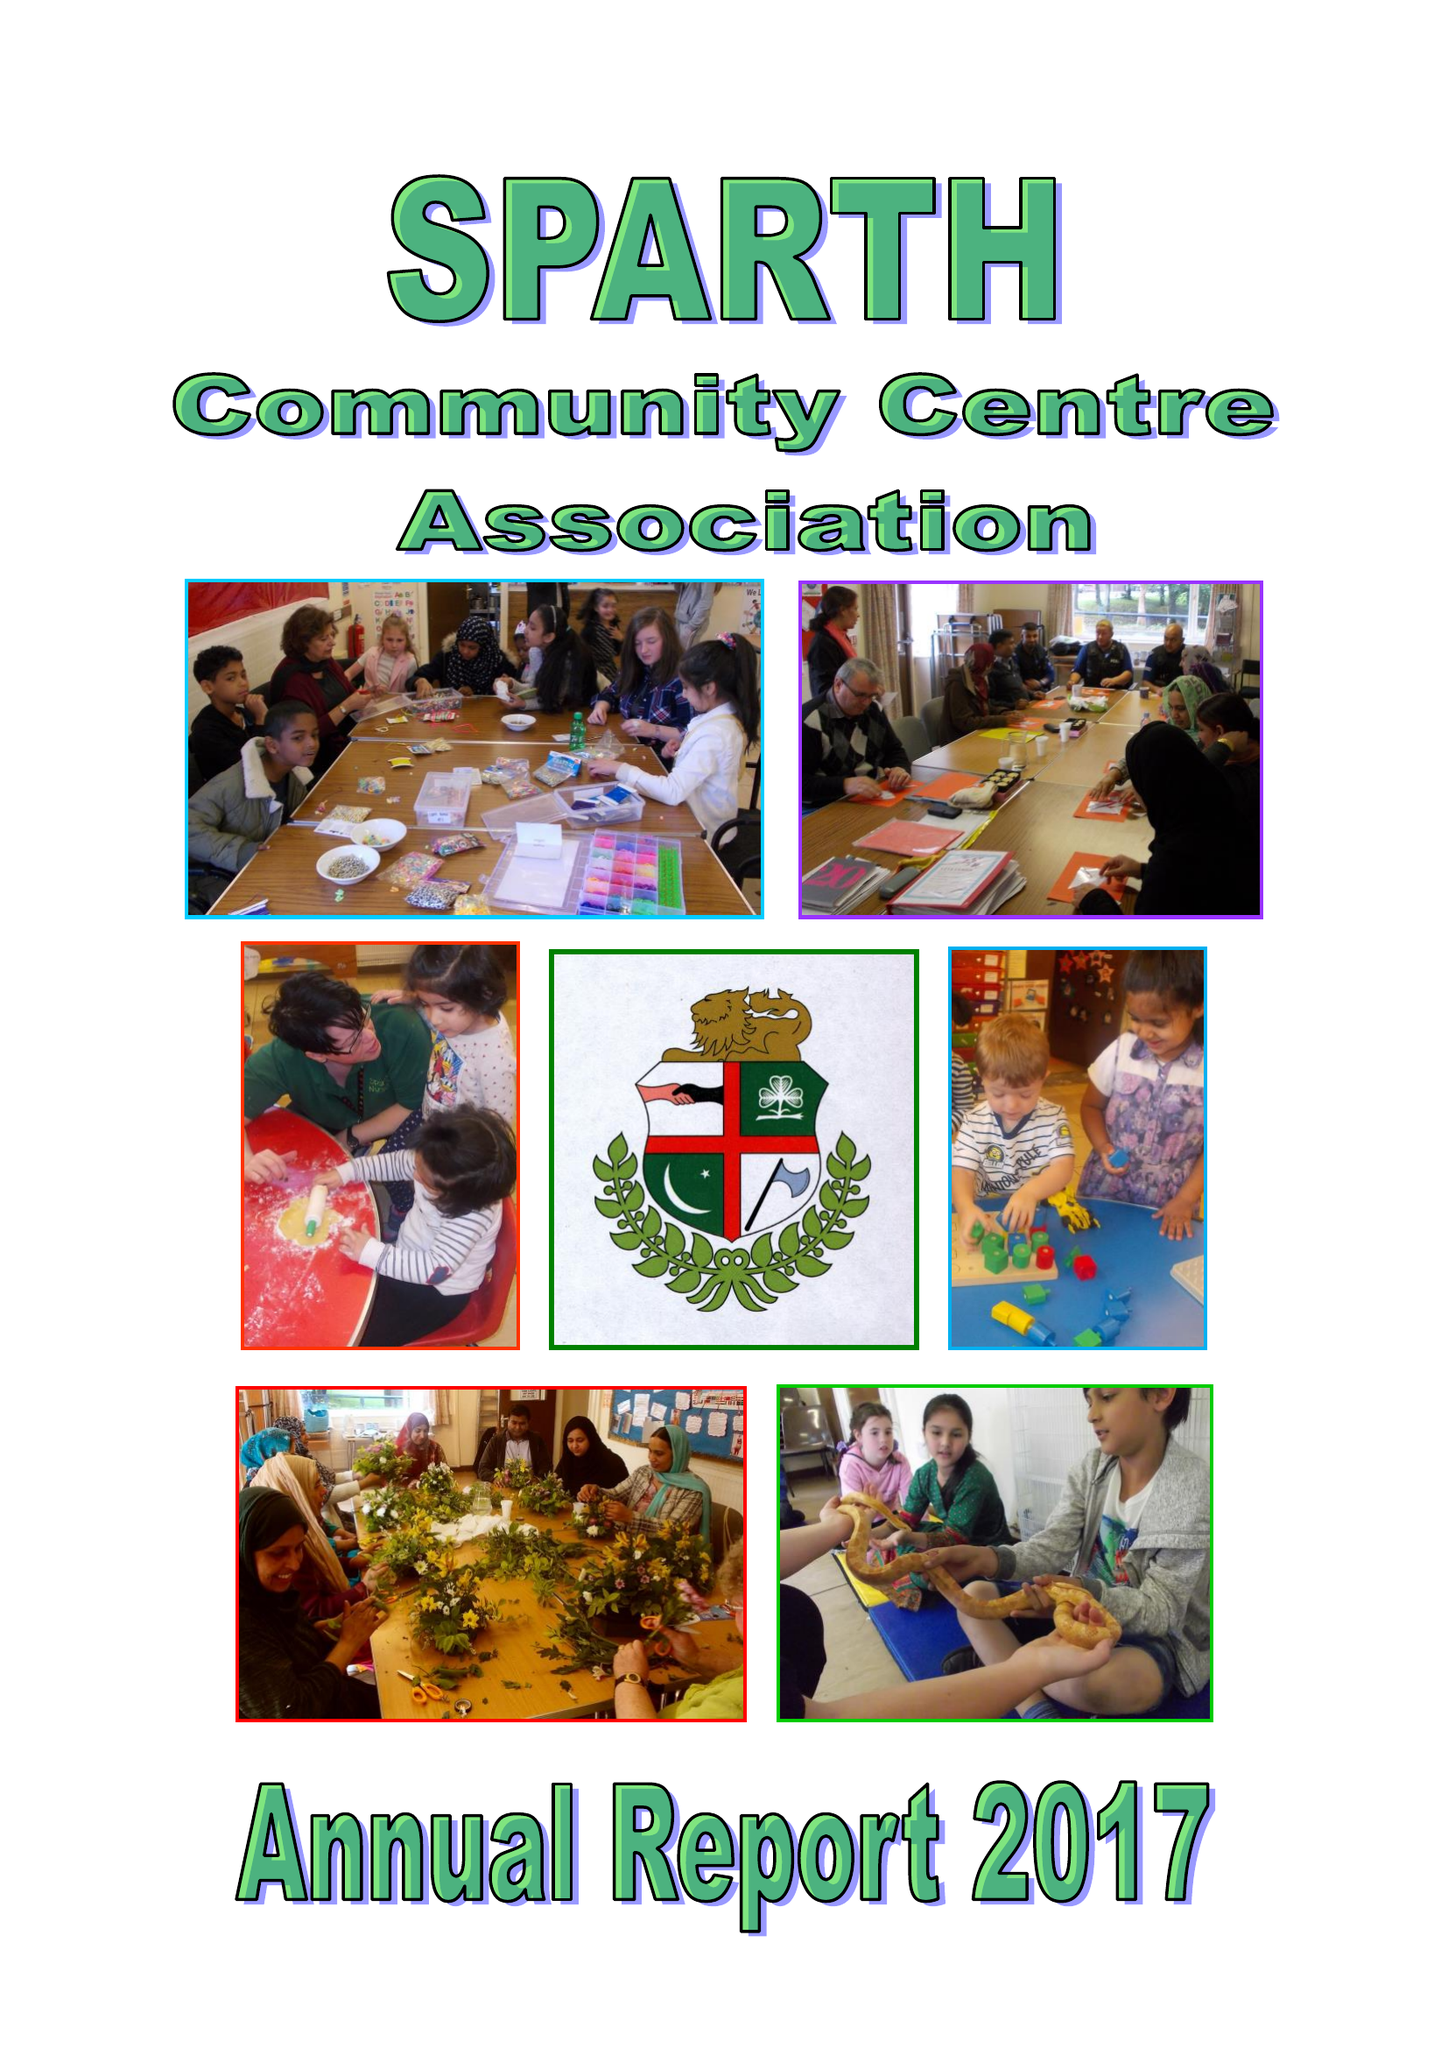What is the value for the income_annually_in_british_pounds?
Answer the question using a single word or phrase. 101777.00 